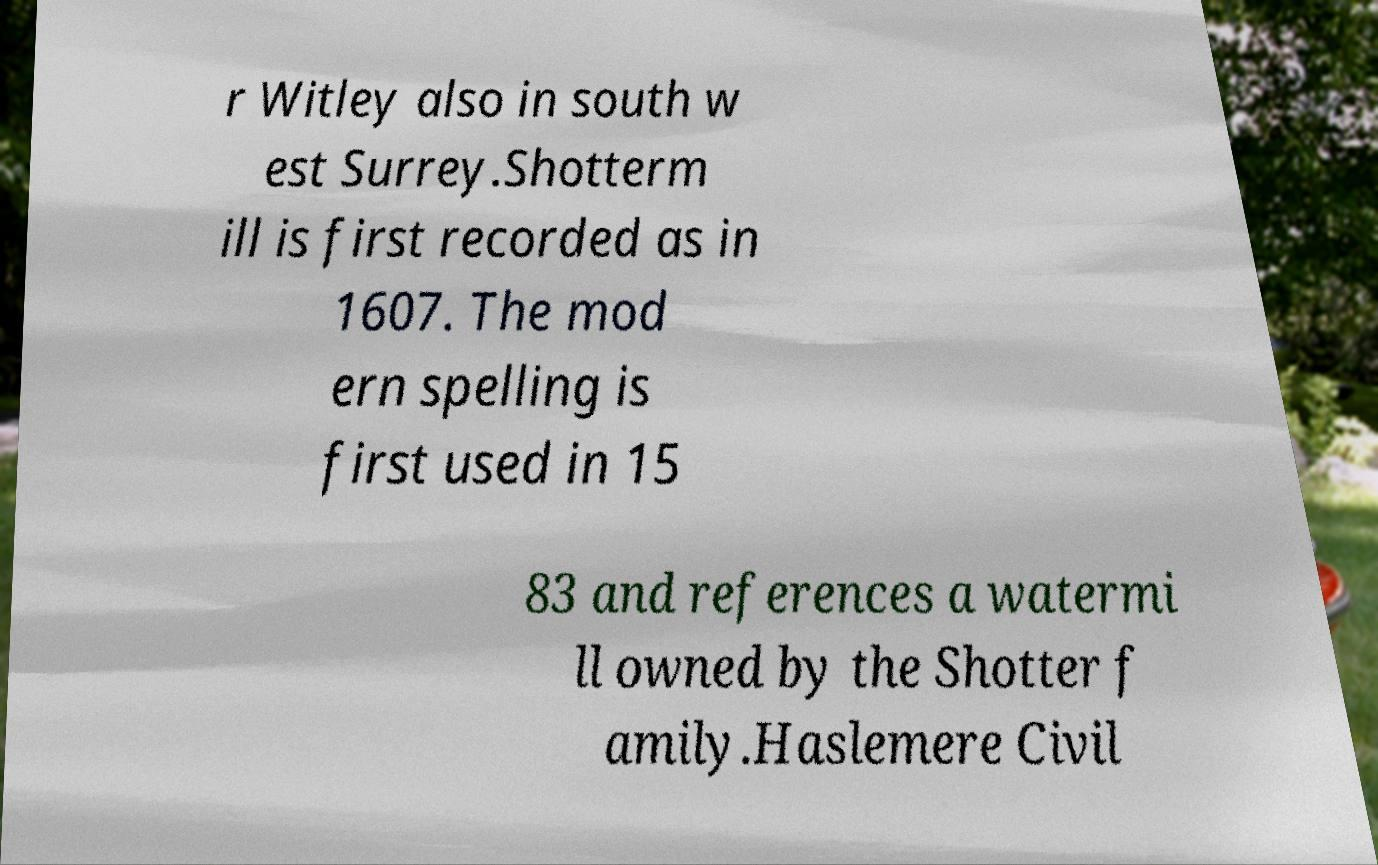There's text embedded in this image that I need extracted. Can you transcribe it verbatim? r Witley also in south w est Surrey.Shotterm ill is first recorded as in 1607. The mod ern spelling is first used in 15 83 and references a watermi ll owned by the Shotter f amily.Haslemere Civil 